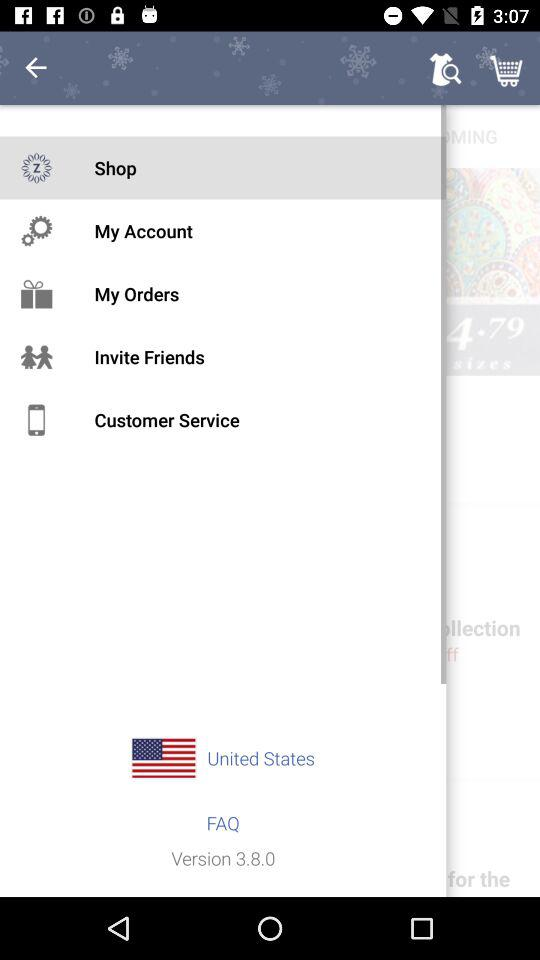What is the version of the app?
Answer the question using a single word or phrase. 3.8.0 